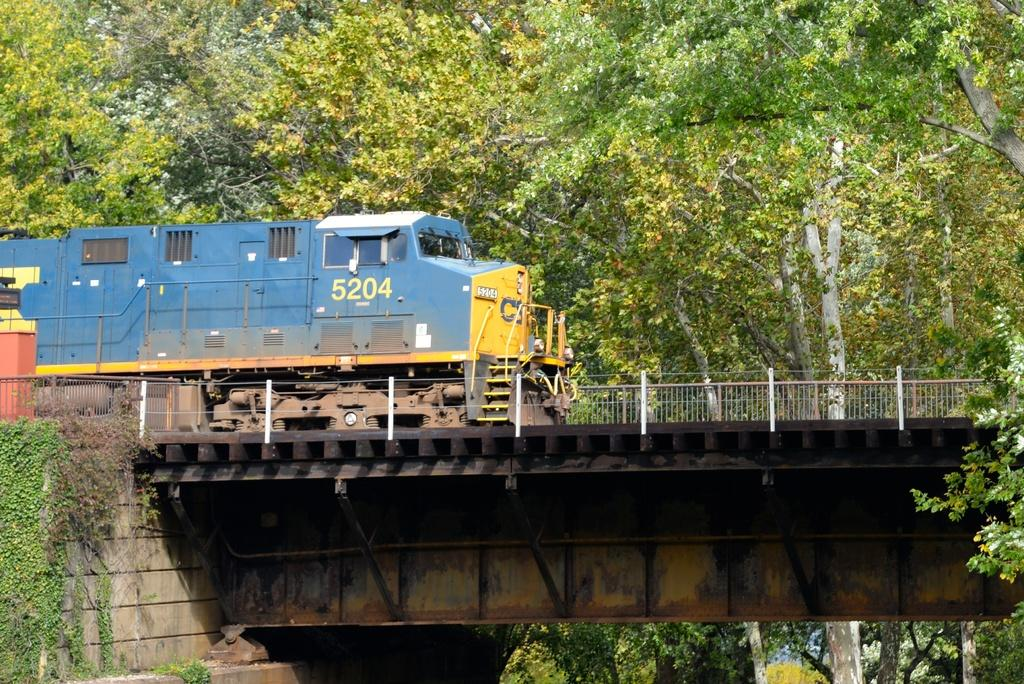<image>
Write a terse but informative summary of the picture. A train goes over a bridge; on the front of the train it says 5204. 